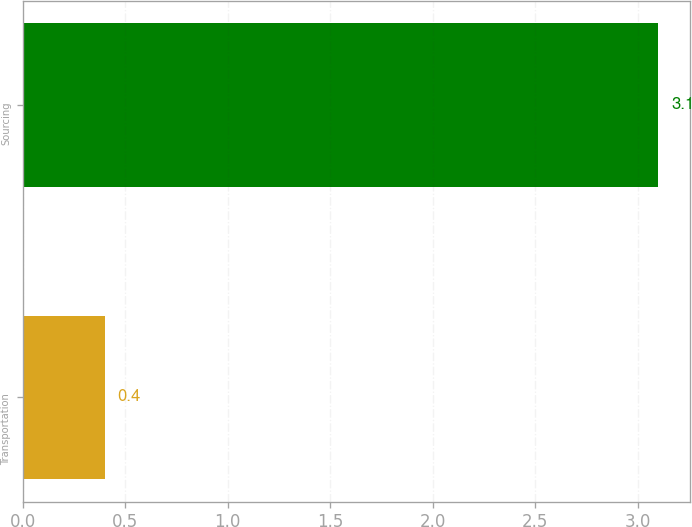Convert chart. <chart><loc_0><loc_0><loc_500><loc_500><bar_chart><fcel>Transportation<fcel>Sourcing<nl><fcel>0.4<fcel>3.1<nl></chart> 